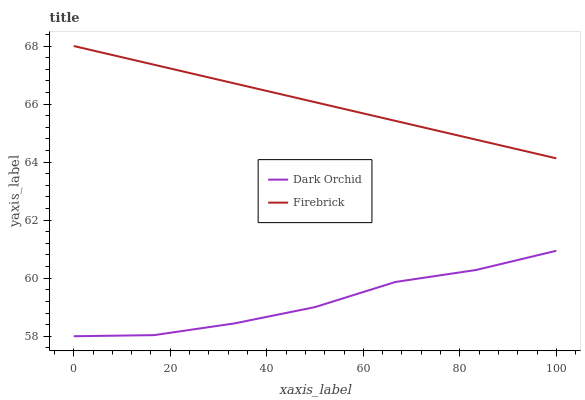Does Dark Orchid have the maximum area under the curve?
Answer yes or no. No. Is Dark Orchid the smoothest?
Answer yes or no. No. Does Dark Orchid have the highest value?
Answer yes or no. No. Is Dark Orchid less than Firebrick?
Answer yes or no. Yes. Is Firebrick greater than Dark Orchid?
Answer yes or no. Yes. Does Dark Orchid intersect Firebrick?
Answer yes or no. No. 